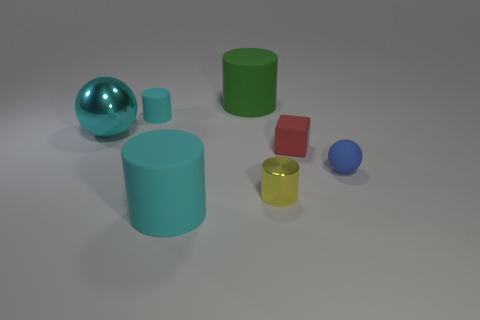There is a tiny object that is the same color as the big metallic sphere; what is it made of?
Make the answer very short. Rubber. What number of objects are cyan rubber cylinders behind the red rubber object or cyan rubber things that are in front of the large cyan ball?
Keep it short and to the point. 2. What number of other objects are there of the same material as the small cube?
Your answer should be very brief. 4. Are the big cylinder that is behind the small yellow cylinder and the small yellow cylinder made of the same material?
Offer a very short reply. No. Is the number of green rubber things that are in front of the small yellow cylinder greater than the number of large shiny things that are in front of the red matte cube?
Offer a terse response. No. How many objects are large cylinders to the right of the big cyan rubber cylinder or large green rubber cylinders?
Your response must be concise. 1. There is a tiny blue object that is made of the same material as the big cyan cylinder; what is its shape?
Offer a terse response. Sphere. Is there anything else that is the same shape as the tiny metal object?
Offer a very short reply. Yes. There is a object that is both in front of the tiny matte ball and right of the big green matte object; what is its color?
Offer a terse response. Yellow. How many blocks are cyan matte things or large cyan shiny things?
Provide a short and direct response. 0. 